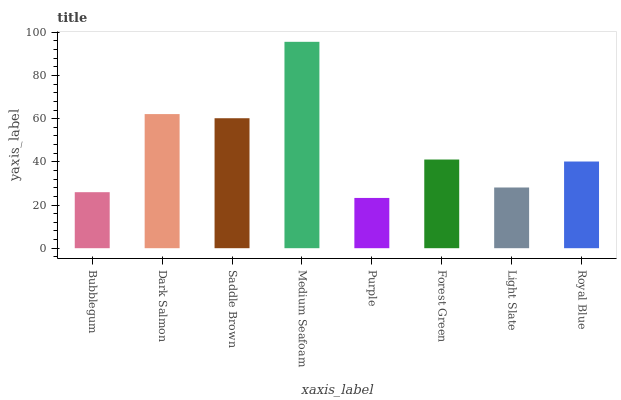Is Purple the minimum?
Answer yes or no. Yes. Is Medium Seafoam the maximum?
Answer yes or no. Yes. Is Dark Salmon the minimum?
Answer yes or no. No. Is Dark Salmon the maximum?
Answer yes or no. No. Is Dark Salmon greater than Bubblegum?
Answer yes or no. Yes. Is Bubblegum less than Dark Salmon?
Answer yes or no. Yes. Is Bubblegum greater than Dark Salmon?
Answer yes or no. No. Is Dark Salmon less than Bubblegum?
Answer yes or no. No. Is Forest Green the high median?
Answer yes or no. Yes. Is Royal Blue the low median?
Answer yes or no. Yes. Is Dark Salmon the high median?
Answer yes or no. No. Is Saddle Brown the low median?
Answer yes or no. No. 